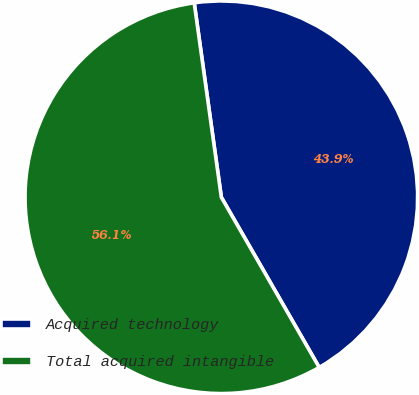<chart> <loc_0><loc_0><loc_500><loc_500><pie_chart><fcel>Acquired technology<fcel>Total acquired intangible<nl><fcel>43.9%<fcel>56.1%<nl></chart> 